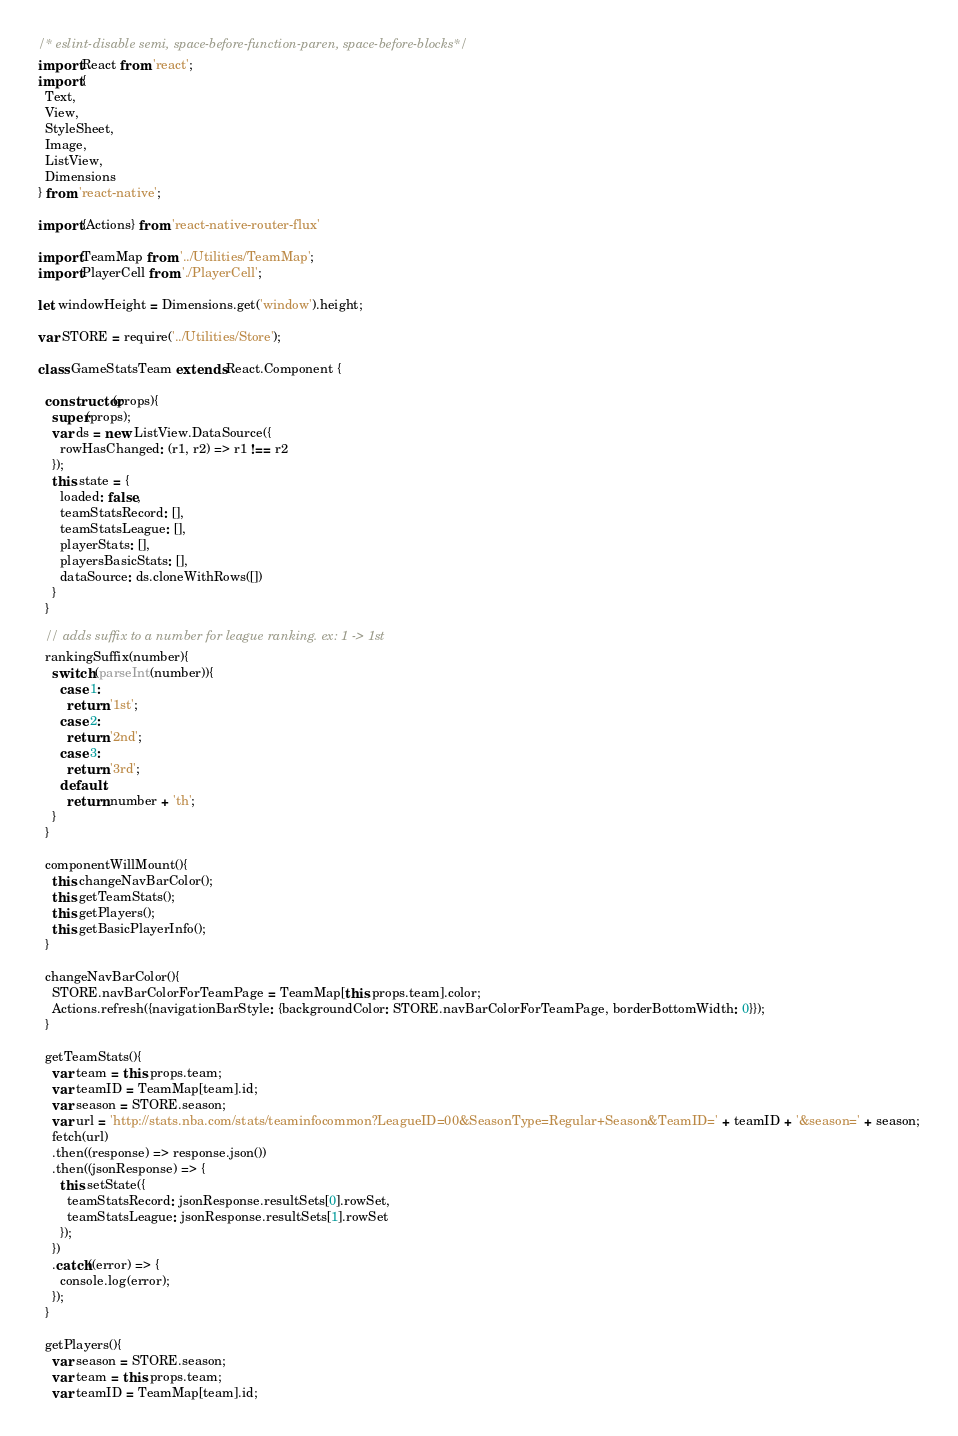<code> <loc_0><loc_0><loc_500><loc_500><_JavaScript_>/* eslint-disable semi, space-before-function-paren, space-before-blocks*/
import React from 'react';
import {
  Text,
  View,
  StyleSheet,
  Image,
  ListView,
  Dimensions
} from 'react-native';

import {Actions} from 'react-native-router-flux'

import TeamMap from '../Utilities/TeamMap';
import PlayerCell from './PlayerCell';

let windowHeight = Dimensions.get('window').height;

var STORE = require('../Utilities/Store');

class GameStatsTeam extends React.Component {

  constructor(props){
    super(props);
    var ds = new ListView.DataSource({
      rowHasChanged: (r1, r2) => r1 !== r2
    });
    this.state = {
      loaded: false,
      teamStatsRecord: [],
      teamStatsLeague: [],
      playerStats: [],
      playersBasicStats: [],
      dataSource: ds.cloneWithRows([])
    }
  }

  // adds suffix to a number for league ranking. ex: 1 -> 1st
  rankingSuffix(number){
    switch (parseInt(number)){
      case 1:
        return '1st';
      case 2:
        return '2nd';
      case 3:
        return '3rd';
      default:
        return number + 'th';
    }
  }

  componentWillMount(){
    this.changeNavBarColor();
    this.getTeamStats();
    this.getPlayers();
    this.getBasicPlayerInfo();
  }

  changeNavBarColor(){
    STORE.navBarColorForTeamPage = TeamMap[this.props.team].color;
    Actions.refresh({navigationBarStyle: {backgroundColor: STORE.navBarColorForTeamPage, borderBottomWidth: 0}});
  }

  getTeamStats(){
    var team = this.props.team;
    var teamID = TeamMap[team].id;
    var season = STORE.season;
    var url = 'http://stats.nba.com/stats/teaminfocommon?LeagueID=00&SeasonType=Regular+Season&TeamID=' + teamID + '&season=' + season;
    fetch(url)
    .then((response) => response.json())
    .then((jsonResponse) => {
      this.setState({
        teamStatsRecord: jsonResponse.resultSets[0].rowSet,
        teamStatsLeague: jsonResponse.resultSets[1].rowSet
      });
    })
    .catch((error) => {
      console.log(error);
    });
  }

  getPlayers(){
    var season = STORE.season;
    var team = this.props.team;
    var teamID = TeamMap[team].id;</code> 